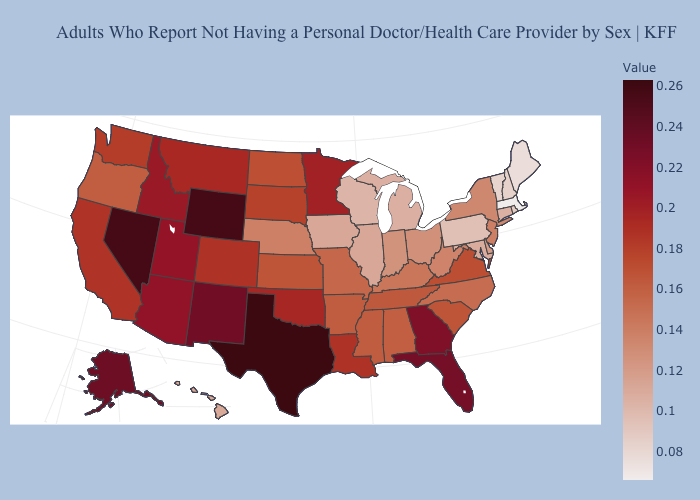Among the states that border Vermont , does Massachusetts have the lowest value?
Keep it brief. Yes. Does the map have missing data?
Keep it brief. No. Does Rhode Island have the highest value in the USA?
Be succinct. No. Among the states that border New Hampshire , does Massachusetts have the highest value?
Short answer required. No. 